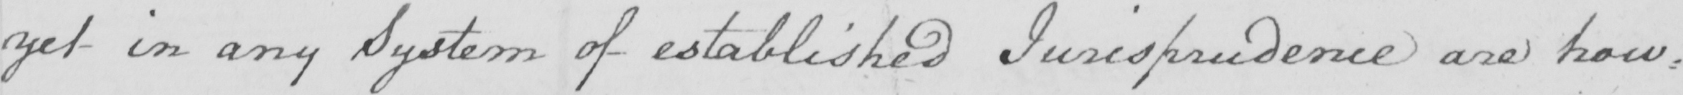Please provide the text content of this handwritten line. yet in any System of established Jurisprudence are how= 